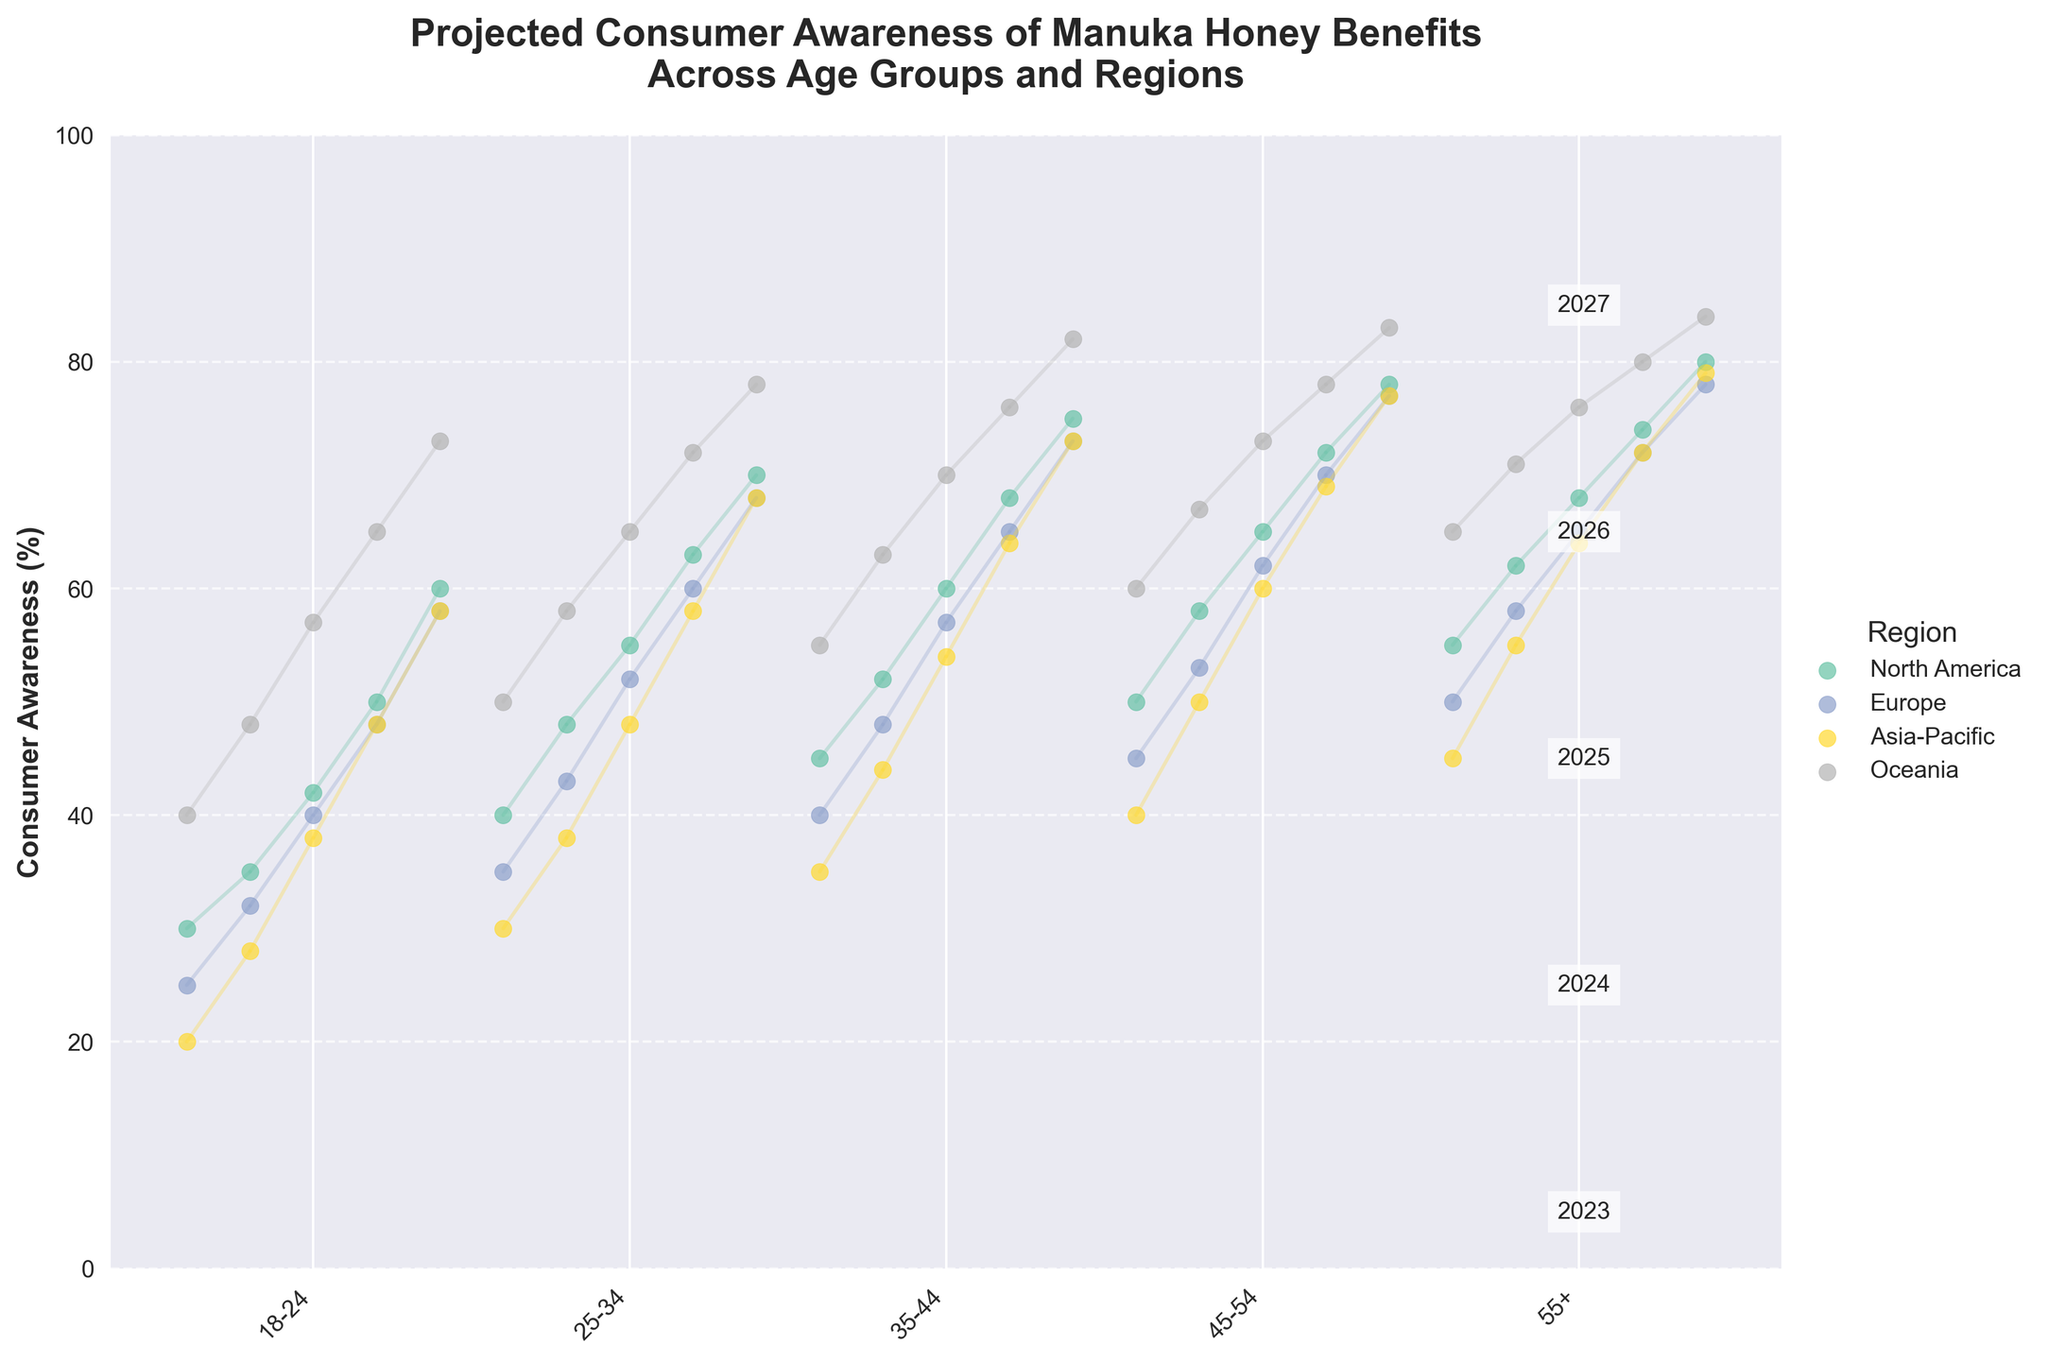What is the title of the chart? The title can be found at the top of the chart and summarizes the data being displayed.
Answer: Projected Consumer Awareness of Manuka Honey Benefits Across Age Groups and Regions What age group in North America has the highest projected consumer awareness in 2023? Locate the North America region and look at the data corresponding to 2023 for each age group. The highest value should be identified.
Answer: 55+ How many age groups are shown in the chart for each region? Count the distinct age group labels on the x-axis.
Answer: 5 Which region is projected to have the lowest consumer awareness for the 18-24 age group in 2027? Check the projected consumer awareness for the 18-24 age group in 2027 across all regions and identify the smallest value.
Answer: North America How does the consumer awareness trend for the 25-34 age group in Oceania change from 2023 to 2027? Examine the plotted points for the 25-34 age group in Oceania from 2023 to 2027 and describe the progression of values.
Answer: Increases In 2025, which region has the highest consumer awareness for the 35-44 age group? Compare the 2025 values for the 35-44 age group across all regions to find the highest value.
Answer: Oceania What is the average projected consumer awareness for the 45-54 age group in Europe from 2023 to 2027? Add the 2023 to 2027 values for the 45-54 age group in Europe and divide by 5 to find the average. (45 + 53 + 62 + 70 + 77) / 5 = 61.4
Answer: 61.4 Which age group in the Asia-Pacific region shows the greatest increase in consumer awareness from 2023 to 2027? Find the difference between the 2023 and 2027 values for each age group in Asia-Pacific and identify the largest increase.
Answer: 18-24 How does the projected consumer awareness for 55+ in Europe compare to 18-24 in Asia-Pacific for 2027? Look at the projected values for 55+ in Europe and 18-24 in Asia-Pacific in 2027 and compare them.
Answer: 55+ in Europe is higher What general trend in consumer awareness can be observed across all regions and age groups? Observe the overall pattern of the plotted points and connecting lines from 2023 to 2027 to determine if there is a common trend.
Answer: Increasing 